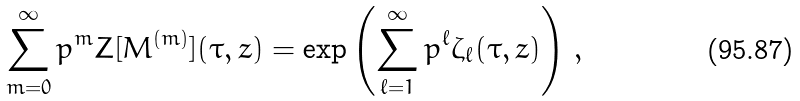Convert formula to latex. <formula><loc_0><loc_0><loc_500><loc_500>\sum _ { m = 0 } ^ { \infty } p ^ { m } Z [ M ^ { ( m ) } ] ( \tau , z ) = \exp \left ( \sum _ { \ell = 1 } ^ { \infty } p ^ { \ell } \zeta _ { \ell } ( \tau , z ) \right ) \, ,</formula> 